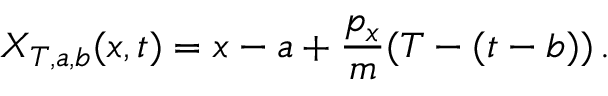<formula> <loc_0><loc_0><loc_500><loc_500>X _ { T , a , b } ( x , t ) = x - a + \frac { p _ { x } } { m } ( T - ( t - b ) ) \, .</formula> 